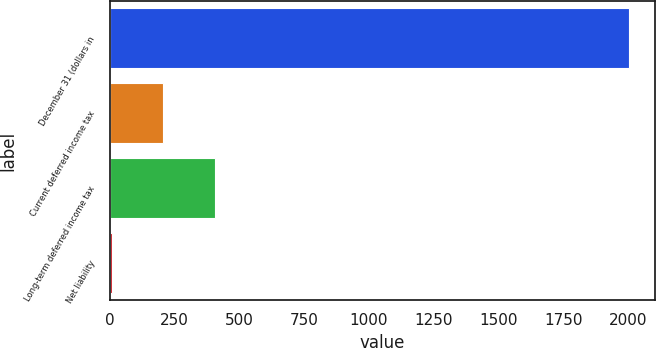<chart> <loc_0><loc_0><loc_500><loc_500><bar_chart><fcel>December 31 (dollars in<fcel>Current deferred income tax<fcel>Long-term deferred income tax<fcel>Net liability<nl><fcel>2003<fcel>205.97<fcel>405.64<fcel>6.3<nl></chart> 